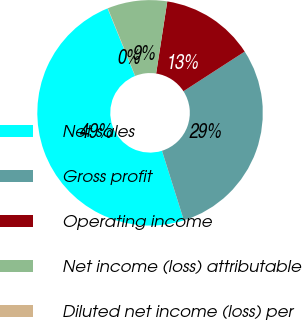<chart> <loc_0><loc_0><loc_500><loc_500><pie_chart><fcel>Net sales<fcel>Gross profit<fcel>Operating income<fcel>Net income (loss) attributable<fcel>Diluted net income (loss) per<nl><fcel>48.71%<fcel>29.29%<fcel>13.42%<fcel>8.55%<fcel>0.04%<nl></chart> 